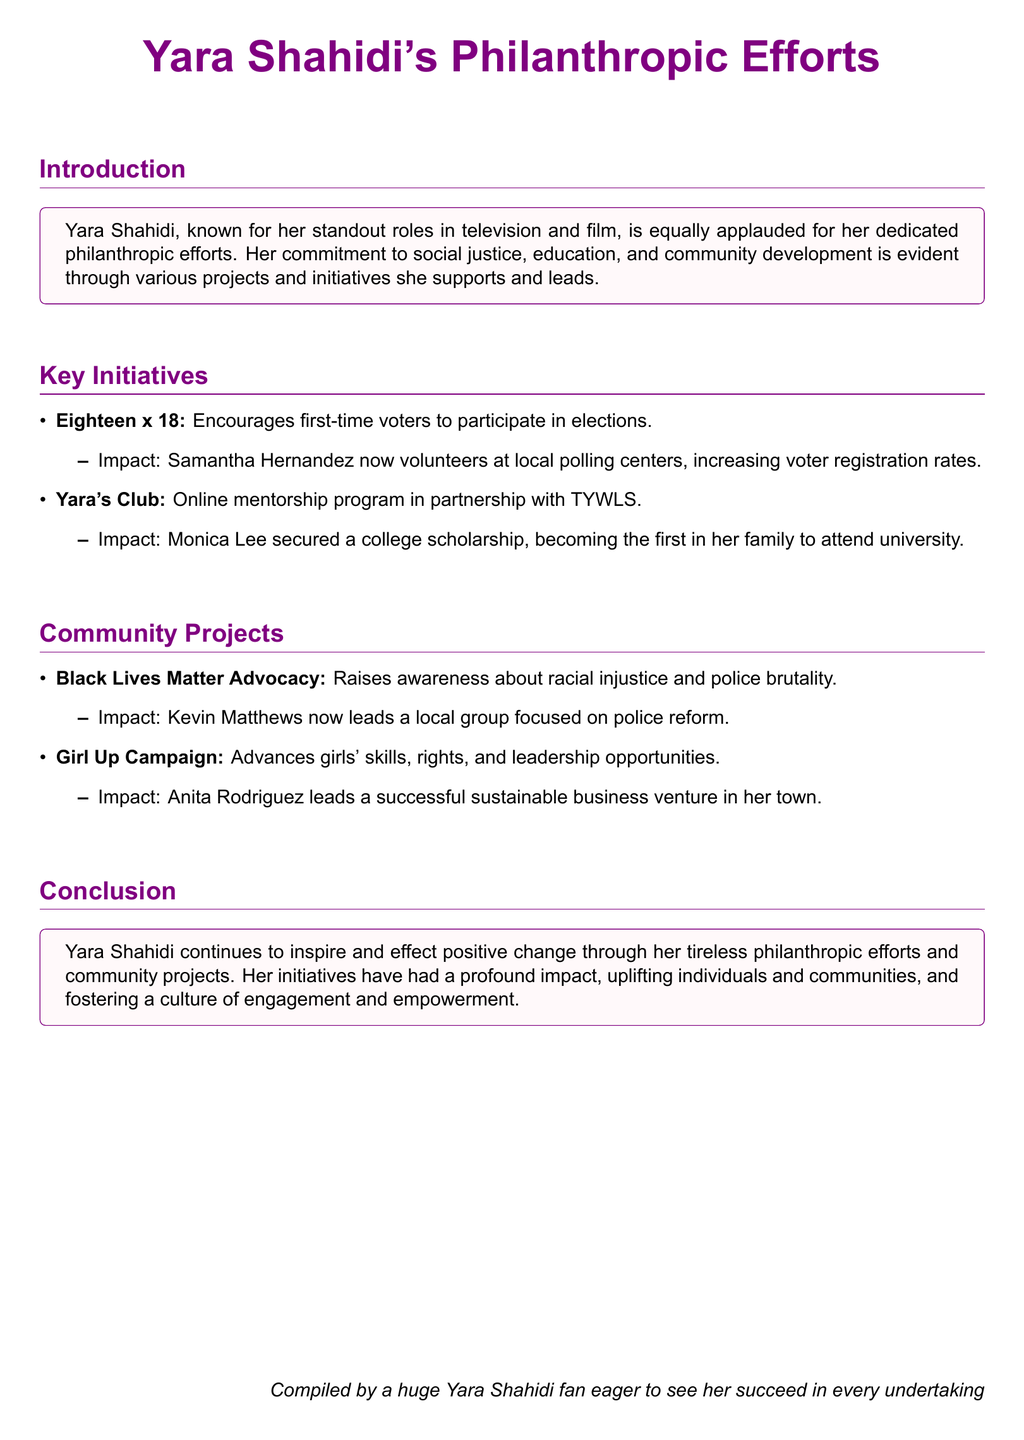What is the name of Yara Shahidi's online mentorship program? The document states that Yara's Club is her online mentorship program in partnership with TYWLS.
Answer: Yara's Club Who is the first in her family to attend university due to Yara's mentorship? The document mentions Monica Lee as a beneficiary who secured a college scholarship, becoming the first in her family to attend university.
Answer: Monica Lee What initiative encourages first-time voters to participate in elections? The document lists Eighteen x 18 as the initiative that encourages first-time voters.
Answer: Eighteen x 18 What is the impact of the Black Lives Matter Advocacy project? The document states that Kevin Matthews now leads a local group focused on police reform due to this advocacy.
Answer: Kevin Matthews Which campaign advances girls' skills and leadership opportunities? The document highlights the Girl Up Campaign as the one that advances girls' skills and leadership opportunities.
Answer: Girl Up Campaign What significant result did Samantha Hernandez achieve through Yara's initiative? The impact noted is that Samantha Hernandez now volunteers at local polling centers, increasing voter registration rates.
Answer: Volunteers at local polling centers What color is used in Yara Shahidi's document theme? The document prominently features yarapurple as the color theme.
Answer: yarapurple How does Yara Shahidi's philanthropic efforts inspire communities? The conclusion of the document states that her efforts uplift individuals and communities, and foster engagement and empowerment.
Answer: Uplifting individuals and communities What role does Anita Rodriguez now lead? The document states that Anita Rodriguez leads a successful sustainable business venture in her town as a result of the Girl Up Campaign.
Answer: Successful sustainable business venture 